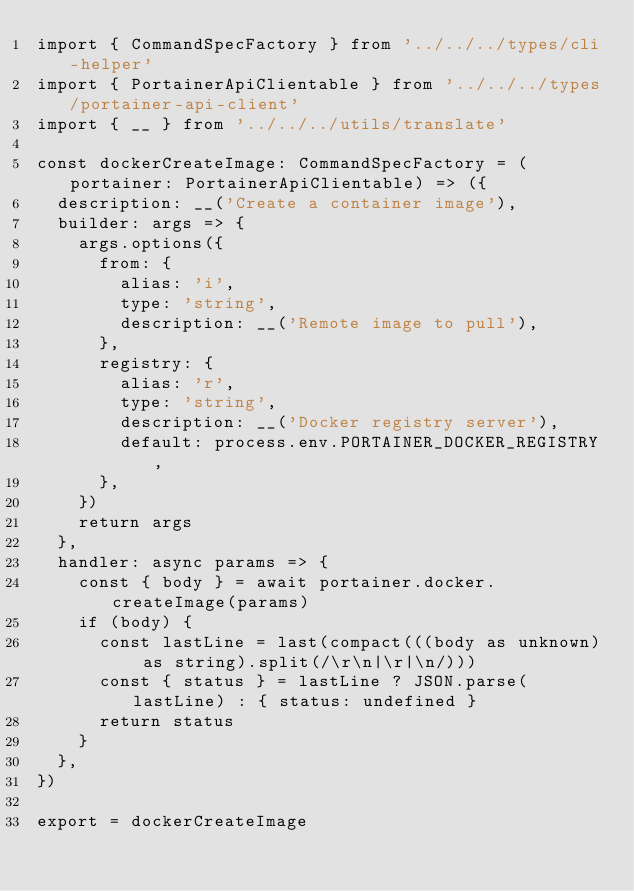Convert code to text. <code><loc_0><loc_0><loc_500><loc_500><_TypeScript_>import { CommandSpecFactory } from '../../../types/cli-helper'
import { PortainerApiClientable } from '../../../types/portainer-api-client'
import { __ } from '../../../utils/translate'

const dockerCreateImage: CommandSpecFactory = (portainer: PortainerApiClientable) => ({
  description: __('Create a container image'),
  builder: args => {
    args.options({
      from: {
        alias: 'i',
        type: 'string',
        description: __('Remote image to pull'),
      },
      registry: {
        alias: 'r',
        type: 'string',
        description: __('Docker registry server'),
        default: process.env.PORTAINER_DOCKER_REGISTRY,
      },
    })
    return args
  },
  handler: async params => {
    const { body } = await portainer.docker.createImage(params)
    if (body) {
      const lastLine = last(compact(((body as unknown) as string).split(/\r\n|\r|\n/)))
      const { status } = lastLine ? JSON.parse(lastLine) : { status: undefined }
      return status
    }
  },
})

export = dockerCreateImage
</code> 